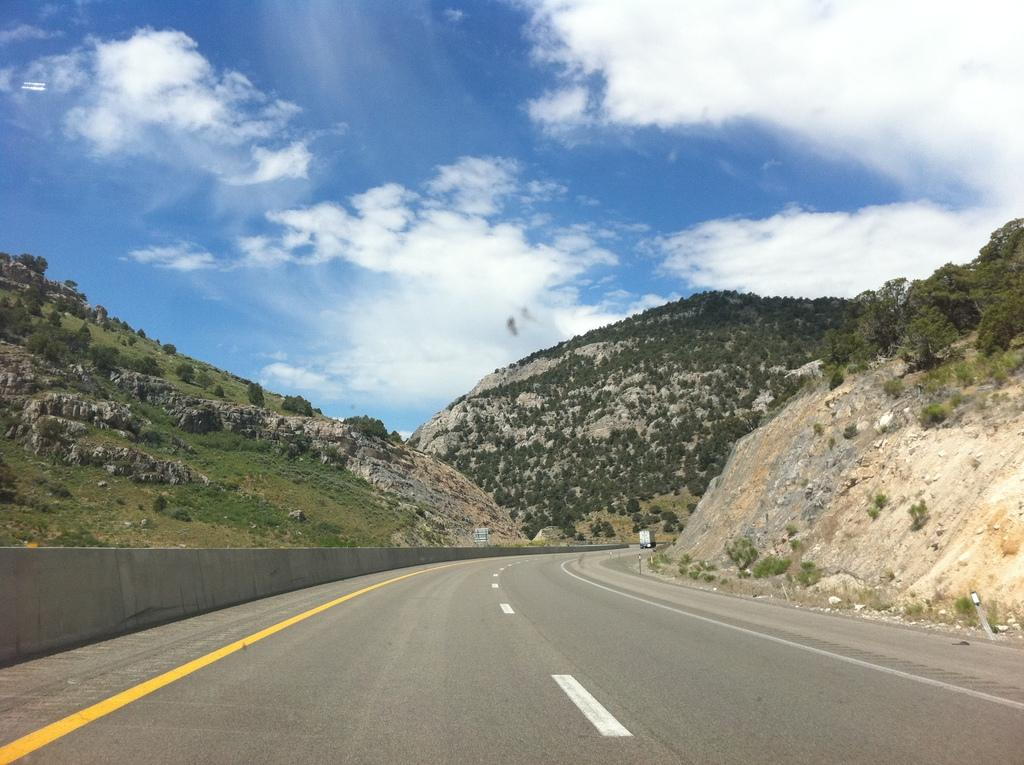What is located at the bottom of the image? There is a road at the bottom of the image. What can be seen in the background of the image? There are mountains in the background of the image. What is visible at the top of the image? The sky is visible at the top of the image. Can you see a volleyball being played in the image? There is no volleyball or any indication of a game being played in the image. Is there any glue visible in the image? There is no glue present in the image. 